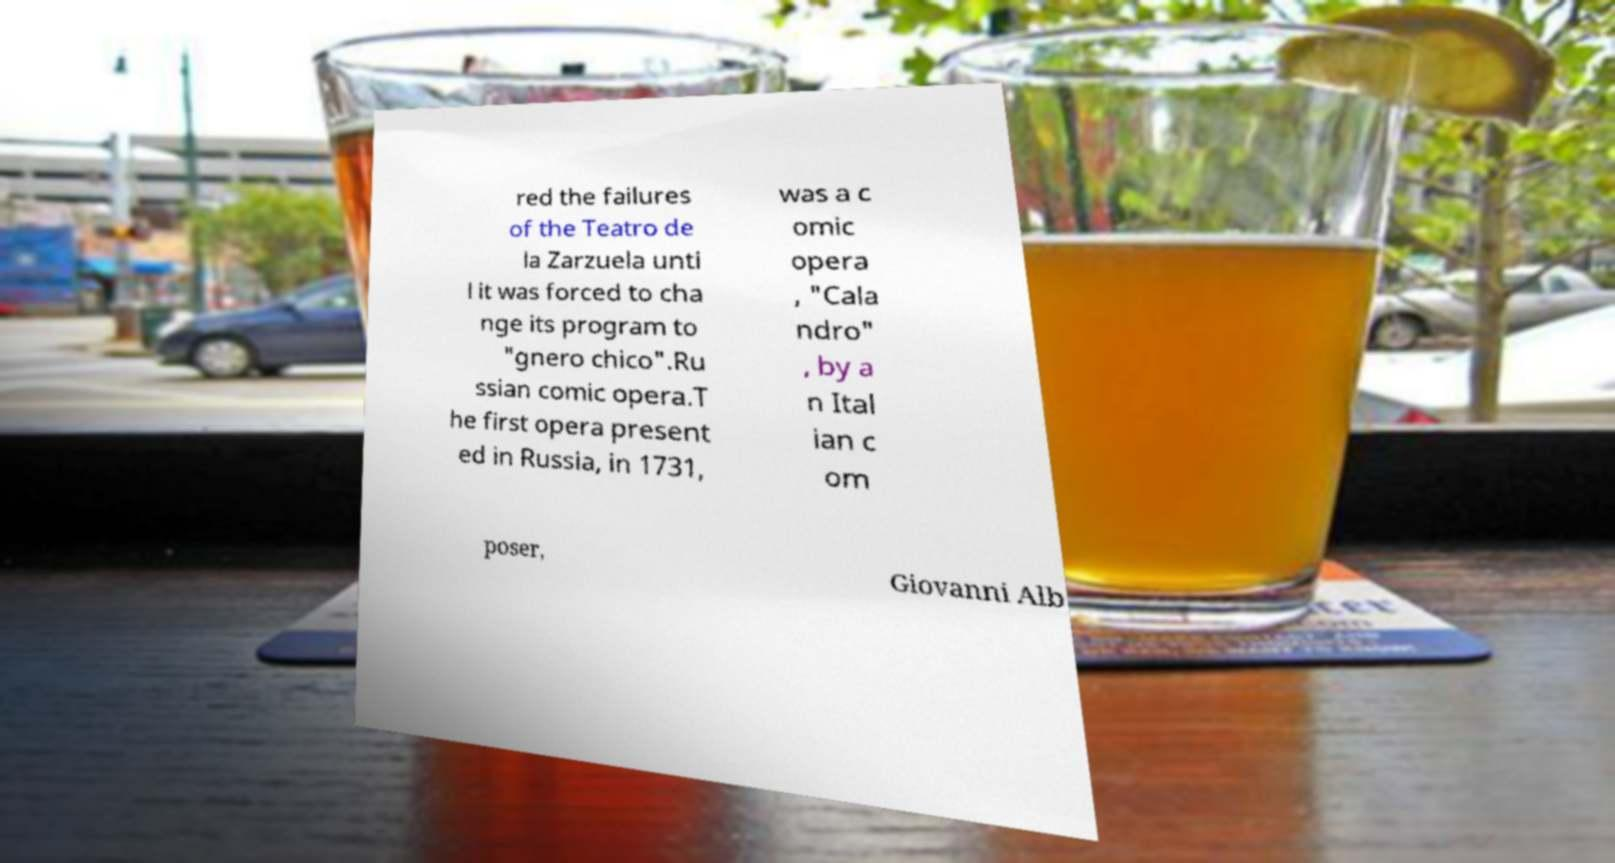Can you read and provide the text displayed in the image?This photo seems to have some interesting text. Can you extract and type it out for me? red the failures of the Teatro de la Zarzuela unti l it was forced to cha nge its program to "gnero chico".Ru ssian comic opera.T he first opera present ed in Russia, in 1731, was a c omic opera , "Cala ndro" , by a n Ital ian c om poser, Giovanni Alb 